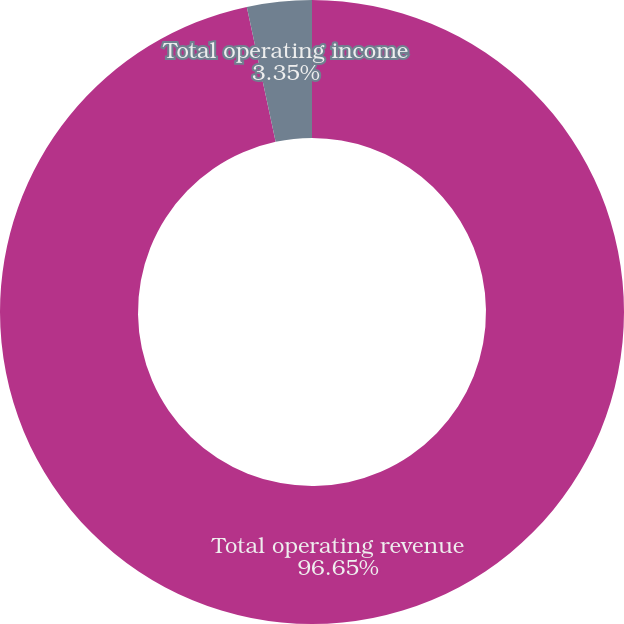<chart> <loc_0><loc_0><loc_500><loc_500><pie_chart><fcel>Total operating revenue<fcel>Total operating income<nl><fcel>96.65%<fcel>3.35%<nl></chart> 